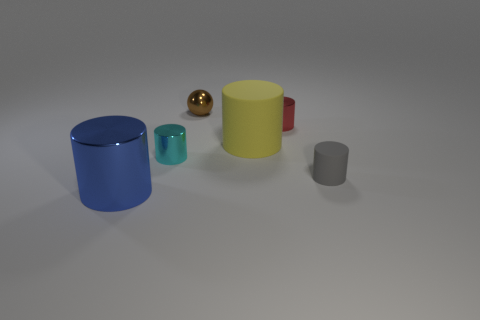If this scenario represented a graph, what could it signify? If interpreted as a graph, the arrangement of objects could signify a trend or a comparison. The varying sizes of the cylinders might represent different quantities or values, with the large blue cylinder being the maximum and the small gray cylinder at the far right being the minimum. The sphere could symbolize an outlier or a unique variable not part of the main trend. 